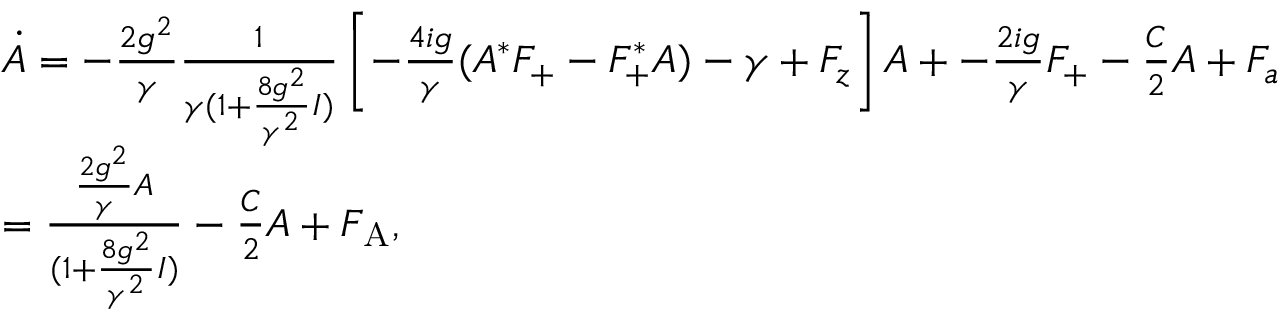Convert formula to latex. <formula><loc_0><loc_0><loc_500><loc_500>\begin{array} { r l } & { \dot { A } = - \frac { 2 g ^ { 2 } } { \gamma } \frac { 1 } { \gamma ( 1 + \frac { 8 g ^ { 2 } } { \gamma ^ { 2 } } I ) } \left [ - \frac { 4 i g } { \gamma } ( A ^ { * } F _ { + } - F _ { + } ^ { * } A ) - \gamma + F _ { z } \right ] A + - \frac { 2 i g } { \gamma } F _ { + } - \frac { C } { 2 } A + F _ { a } } \\ & { = \frac { \frac { 2 g ^ { 2 } } { \gamma } A } { ( 1 + \frac { 8 g ^ { 2 } } { \gamma ^ { 2 } } I ) } - \frac { C } { 2 } A + F _ { A } , } \end{array}</formula> 